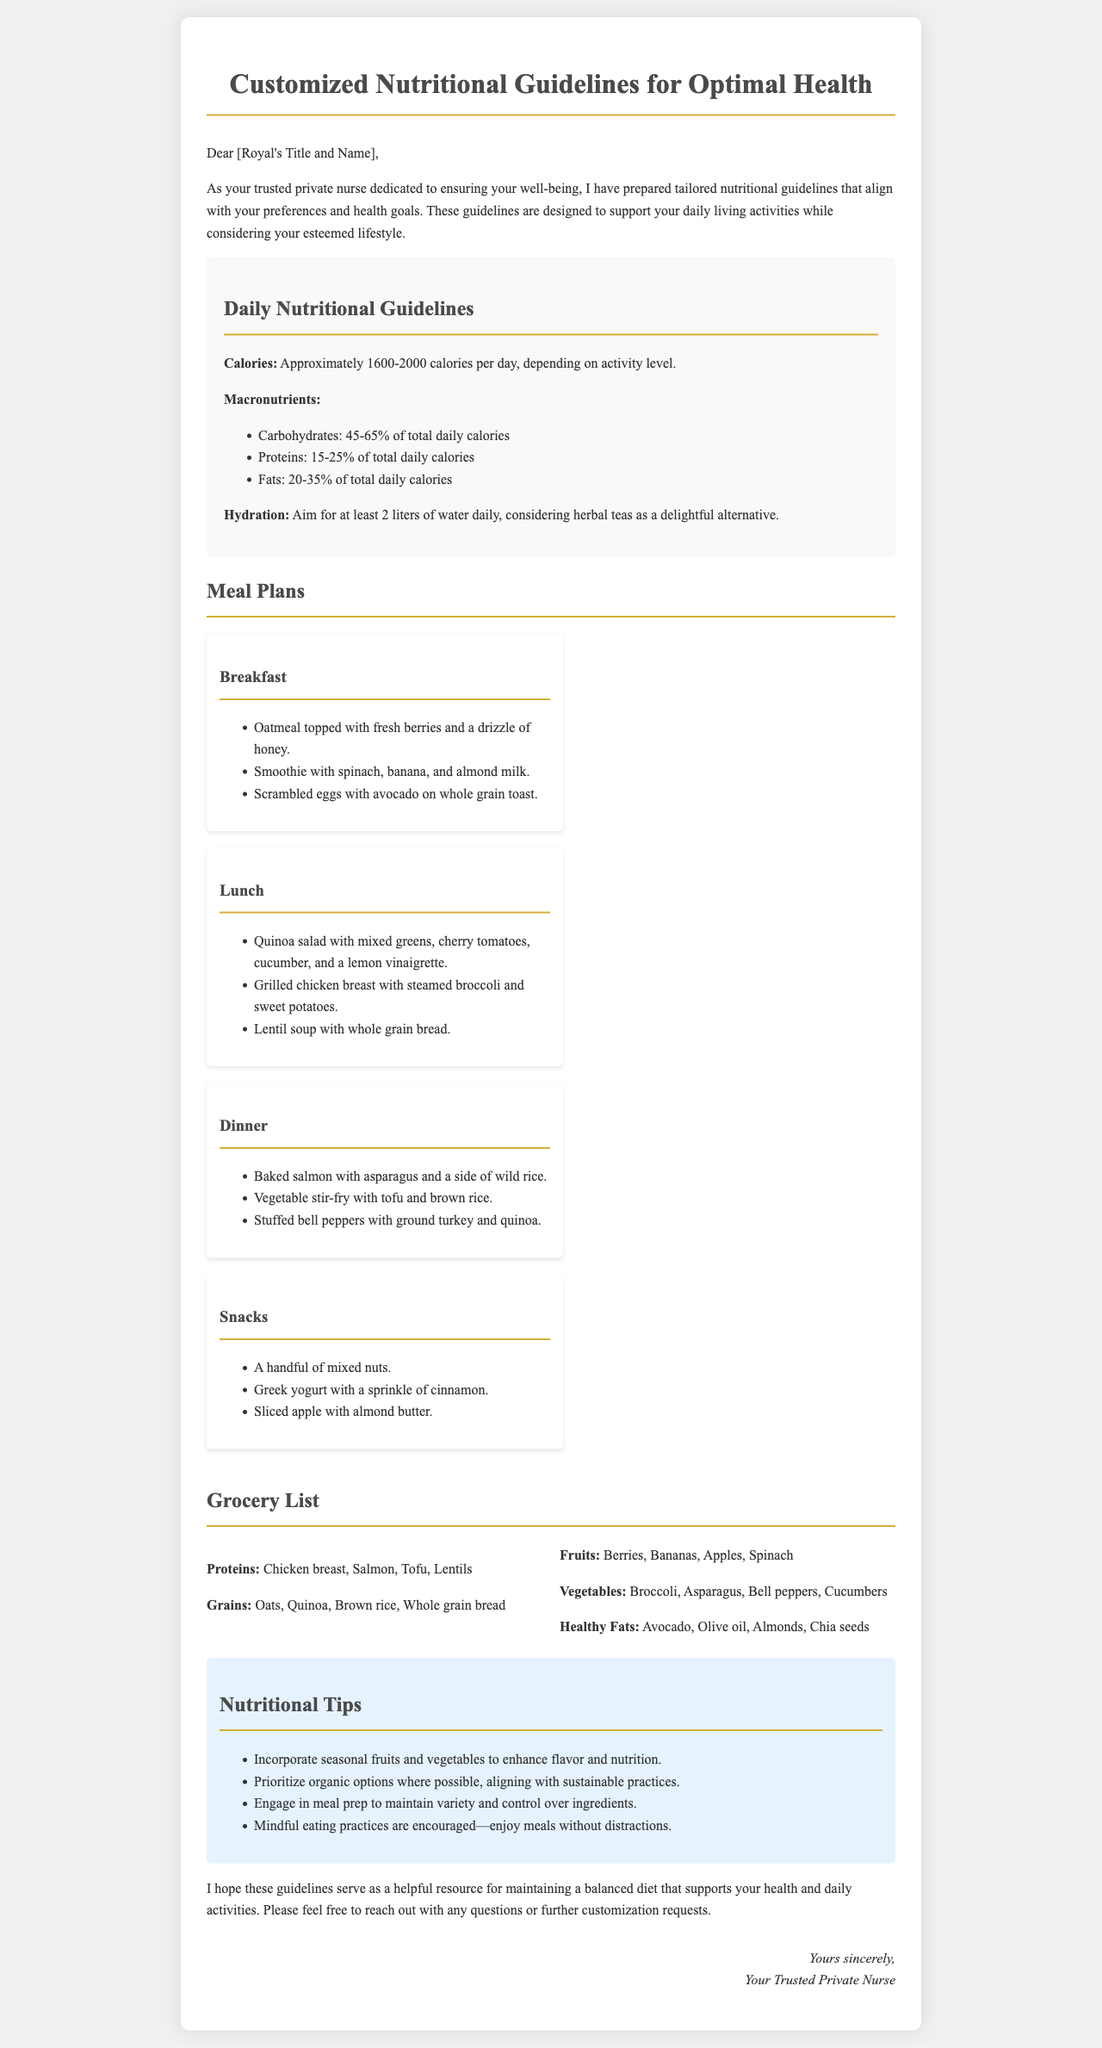what is the recommended daily calorie intake? The document states that the recommended daily calorie intake is approximately 1600-2000 calories per day, depending on activity level.
Answer: 1600-2000 calories what percentage of daily calories should come from proteins? The guidelines indicate that proteins should account for 15-25% of total daily calories.
Answer: 15-25% what beverage is suggested as an alternative to water? The document suggests herbal teas as a delightful alternative to water for hydration.
Answer: herbal teas list two proteins recommended in the grocery list. The grocery list mentions chicken breast and salmon as proteins.
Answer: chicken breast, salmon what is one of the nutritional tips provided? The tips section advises to incorporate seasonal fruits and vegetables to enhance flavor and nutrition.
Answer: incorporate seasonal fruits and vegetables how many meals are included in the meal plans? The meal plans feature four distinct categories: breakfast, lunch, dinner, and snacks, making a total of four meals.
Answer: four meals what ingredient is suggested for healthy fats in the grocery list? The grocery list includes avocado as one of the healthy fats recommended.
Answer: avocado which meal includes oatmeal? Oatmeal is included in the breakfast meal plan.
Answer: breakfast what type of document is this? The document is a set of customized nutritional guidelines.
Answer: nutritional guidelines 